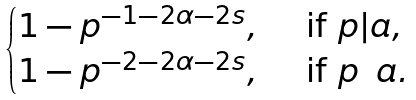Convert formula to latex. <formula><loc_0><loc_0><loc_500><loc_500>\begin{cases} 1 - p ^ { - 1 - 2 \alpha - 2 s } , \quad \text { if } p | a , \\ 1 - p ^ { - 2 - 2 \alpha - 2 s } , \quad \text { if } p \nmid a . \end{cases}</formula> 